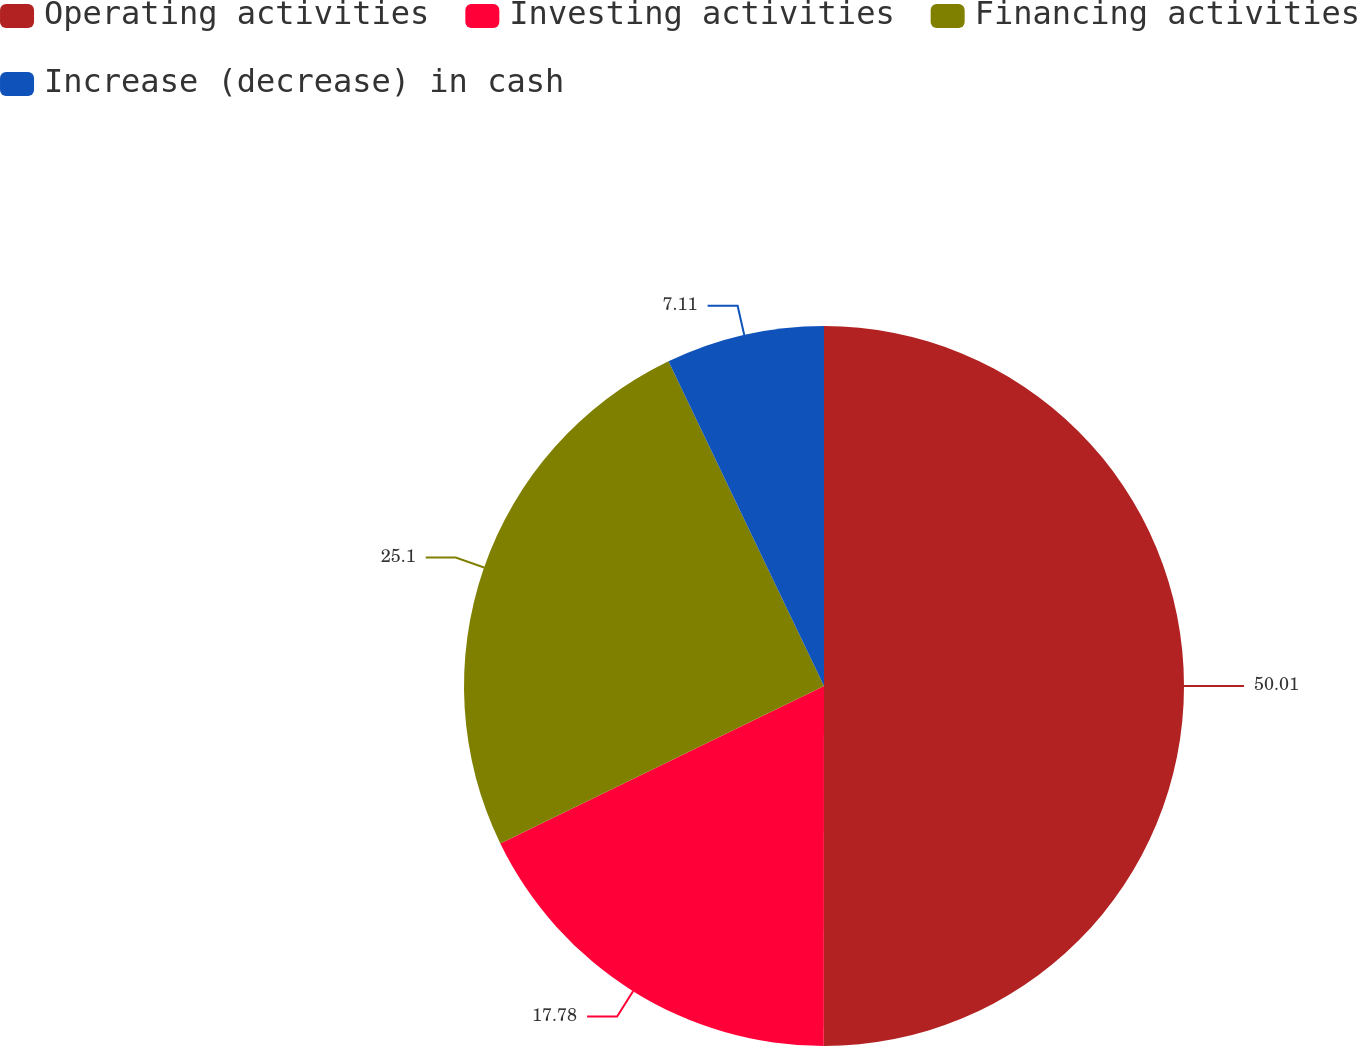Convert chart. <chart><loc_0><loc_0><loc_500><loc_500><pie_chart><fcel>Operating activities<fcel>Investing activities<fcel>Financing activities<fcel>Increase (decrease) in cash<nl><fcel>50.01%<fcel>17.78%<fcel>25.1%<fcel>7.11%<nl></chart> 